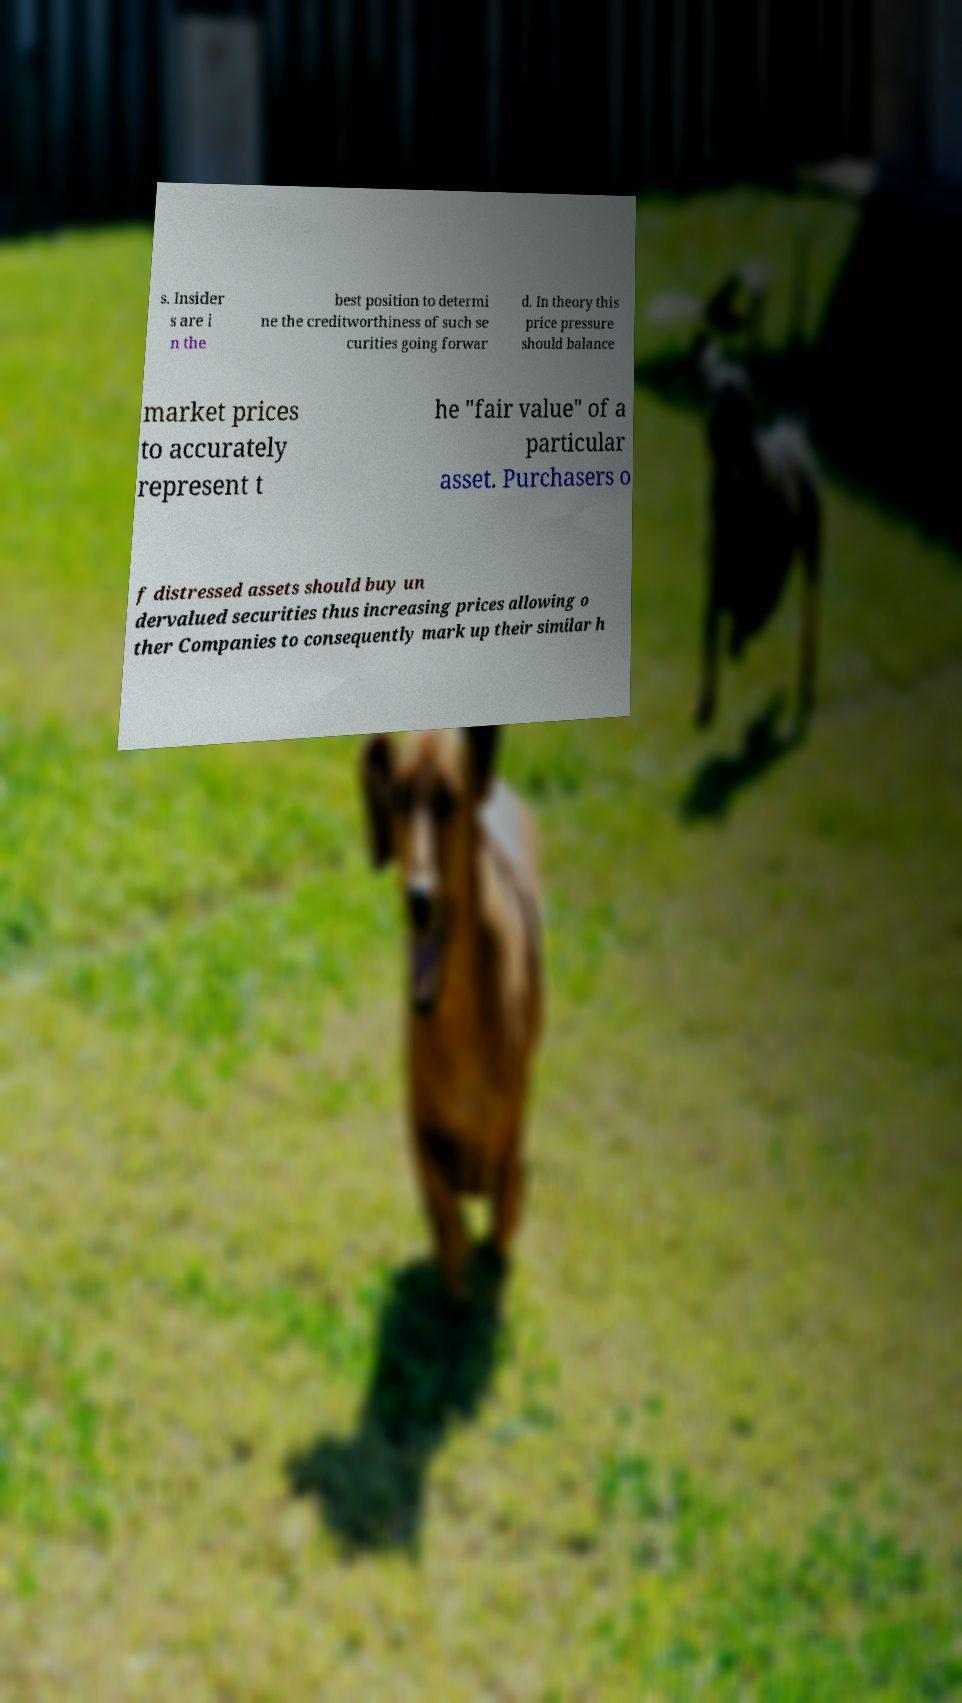Can you read and provide the text displayed in the image?This photo seems to have some interesting text. Can you extract and type it out for me? s. Insider s are i n the best position to determi ne the creditworthiness of such se curities going forwar d. In theory this price pressure should balance market prices to accurately represent t he "fair value" of a particular asset. Purchasers o f distressed assets should buy un dervalued securities thus increasing prices allowing o ther Companies to consequently mark up their similar h 